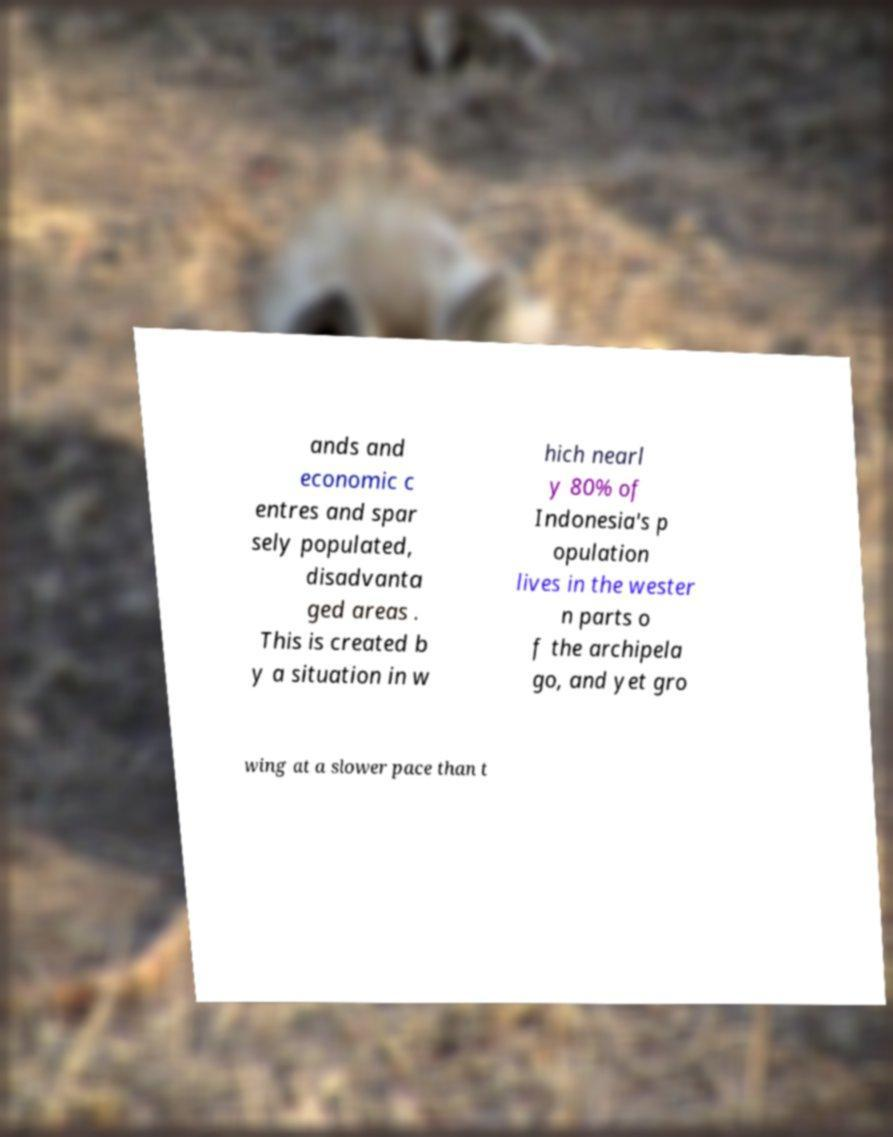Can you read and provide the text displayed in the image?This photo seems to have some interesting text. Can you extract and type it out for me? ands and economic c entres and spar sely populated, disadvanta ged areas . This is created b y a situation in w hich nearl y 80% of Indonesia's p opulation lives in the wester n parts o f the archipela go, and yet gro wing at a slower pace than t 